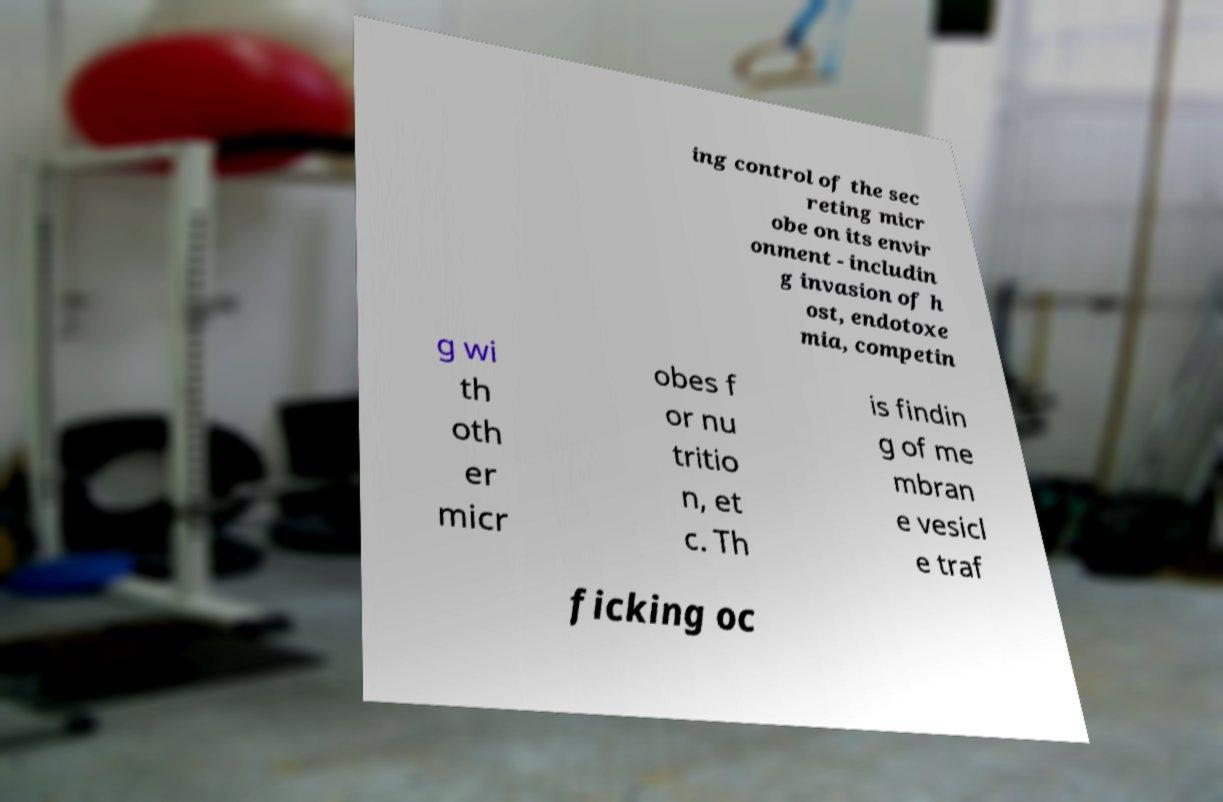Can you accurately transcribe the text from the provided image for me? ing control of the sec reting micr obe on its envir onment - includin g invasion of h ost, endotoxe mia, competin g wi th oth er micr obes f or nu tritio n, et c. Th is findin g of me mbran e vesicl e traf ficking oc 